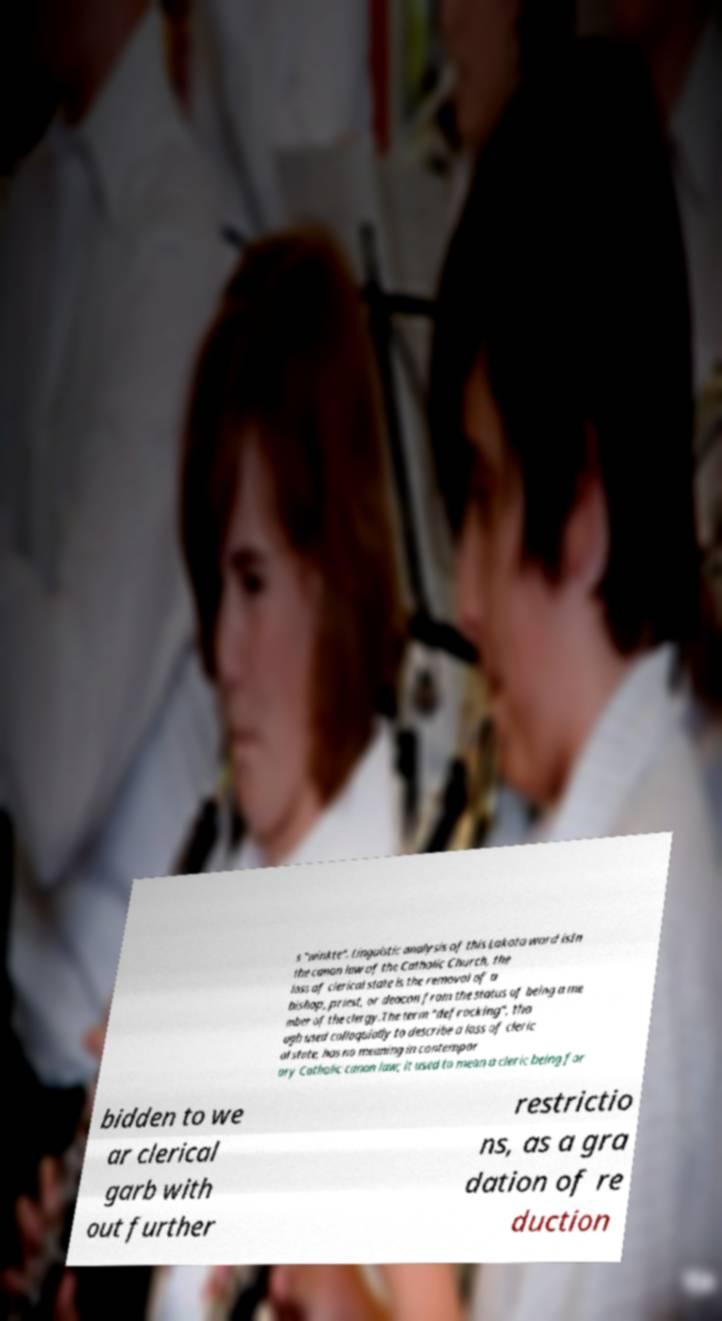Could you extract and type out the text from this image? s "winkte". Linguistic analysis of this Lakota word isIn the canon law of the Catholic Church, the loss of clerical state is the removal of a bishop, priest, or deacon from the status of being a me mber of the clergy.The term "defrocking", tho ugh used colloquially to describe a loss of cleric al state, has no meaning in contempor ary Catholic canon law; it used to mean a cleric being for bidden to we ar clerical garb with out further restrictio ns, as a gra dation of re duction 